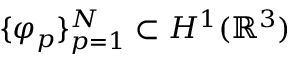Convert formula to latex. <formula><loc_0><loc_0><loc_500><loc_500>\{ \varphi _ { p } \} _ { p = 1 } ^ { N } \subset H ^ { 1 } ( \mathbb { R } ^ { 3 } )</formula> 